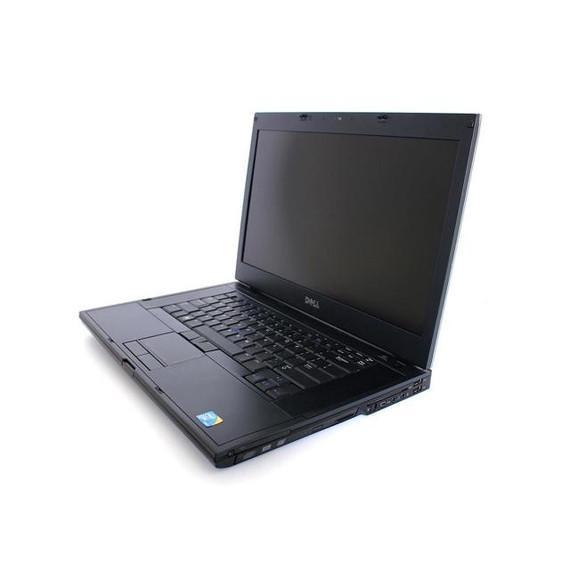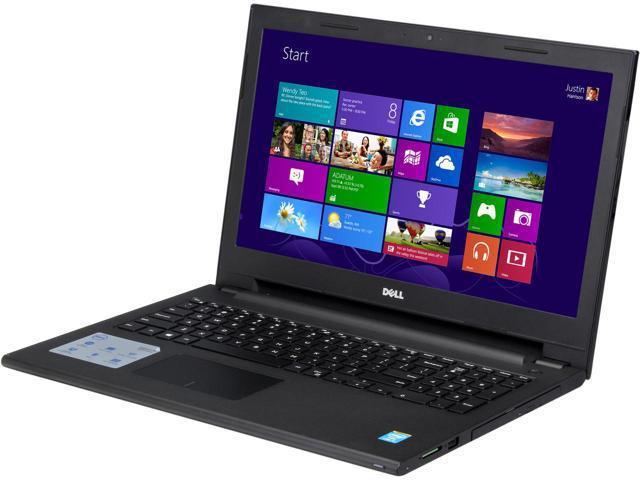The first image is the image on the left, the second image is the image on the right. For the images shown, is this caption "The right and left images contain the same number of laptops." true? Answer yes or no. Yes. The first image is the image on the left, the second image is the image on the right. Analyze the images presented: Is the assertion "One of the images contains exactly three computers" valid? Answer yes or no. No. 